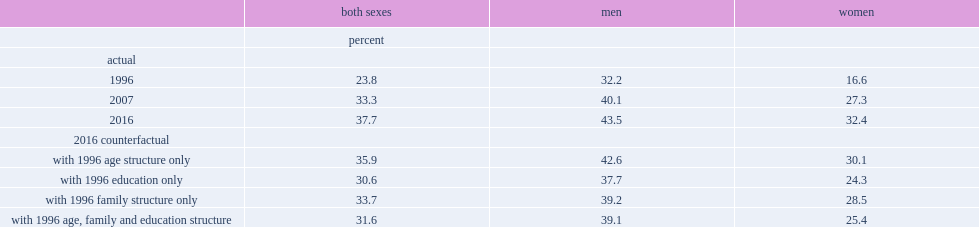Which year would have a higher participation rate if educational factors had been held constant, 1996 or 2016? 2016 counterfactual. How much would the participation rate have increased from 1996 to 2016 if family factors had been held constant over the period? 9.9. How much would the participation rate have increased, if the age structure had remained the same as in 1996? 12.1. How much did the participation rate increase from 1996 to 2016? 13.9. How much would the participation rate have increased when all factors are considered together in the model? 7.8. How much would the participation have increased among men if all of these factors had been held constant? 6.9. How much did the participation increased among men from 1996 to 2016? 11.3. What percentage of the overall increase in the participation rate of men from 1996 to 2016 was caused by compositional effects? 0.389381. How much increase in the participation rate would be caused holding age, family status and education constant? 8.8. How much increase in the participation rate did older women eventually achieve from 1996 to 2016? 15.8. What percentage of overall change in participation rates among women was caused by compositional effects? 0.443038. What percentage of overall change in participation rates among women was caused by non-compositional effects? 0.556962. 